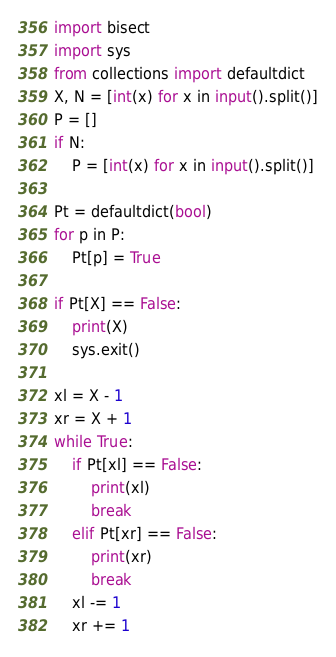Convert code to text. <code><loc_0><loc_0><loc_500><loc_500><_Python_>import bisect
import sys
from collections import defaultdict
X, N = [int(x) for x in input().split()]
P = []
if N:
    P = [int(x) for x in input().split()]

Pt = defaultdict(bool)
for p in P:
    Pt[p] = True

if Pt[X] == False:
    print(X)
    sys.exit()

xl = X - 1
xr = X + 1
while True:
    if Pt[xl] == False:
        print(xl)
        break
    elif Pt[xr] == False:
        print(xr)
        break
    xl -= 1
    xr += 1</code> 